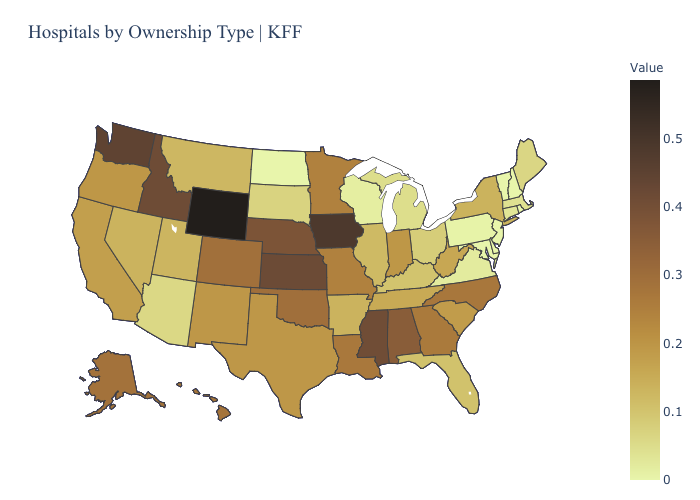Does the map have missing data?
Answer briefly. No. Does North Dakota have the lowest value in the USA?
Concise answer only. Yes. Does Alabama have a higher value than Iowa?
Answer briefly. No. Does Mississippi have the highest value in the USA?
Be succinct. No. Among the states that border Mississippi , which have the highest value?
Keep it brief. Alabama. Does Nebraska have the lowest value in the MidWest?
Keep it brief. No. Which states have the highest value in the USA?
Quick response, please. Wyoming. Which states have the lowest value in the USA?
Write a very short answer. Delaware, Maryland, New Hampshire, New Jersey, North Dakota, Rhode Island, Vermont. 